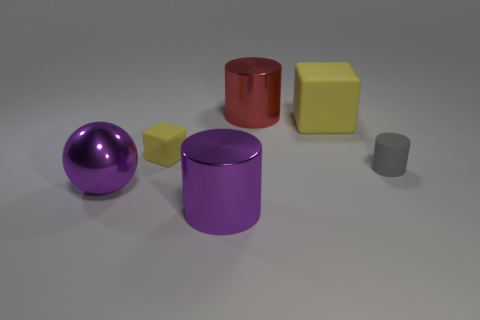What shape is the metal thing that is the same color as the shiny sphere?
Your answer should be compact. Cylinder. What size is the red thing that is the same material as the large purple ball?
Provide a succinct answer. Large. There is a shiny object that is behind the purple metallic cylinder and in front of the large matte block; what is its size?
Provide a succinct answer. Large. What is the material of the big purple object that is the same shape as the small gray object?
Provide a short and direct response. Metal. Is the shape of the big yellow matte thing the same as the gray object?
Make the answer very short. No. Is there anything else of the same color as the small cube?
Your answer should be compact. Yes. There is a red shiny object; does it have the same shape as the big object right of the red object?
Your answer should be very brief. No. There is a rubber block left of the metallic cylinder that is left of the big shiny cylinder behind the rubber cylinder; what color is it?
Keep it short and to the point. Yellow. Is the shape of the metallic object that is behind the big purple metallic ball the same as  the tiny gray thing?
Provide a succinct answer. Yes. What is the material of the large purple cylinder?
Offer a terse response. Metal. 